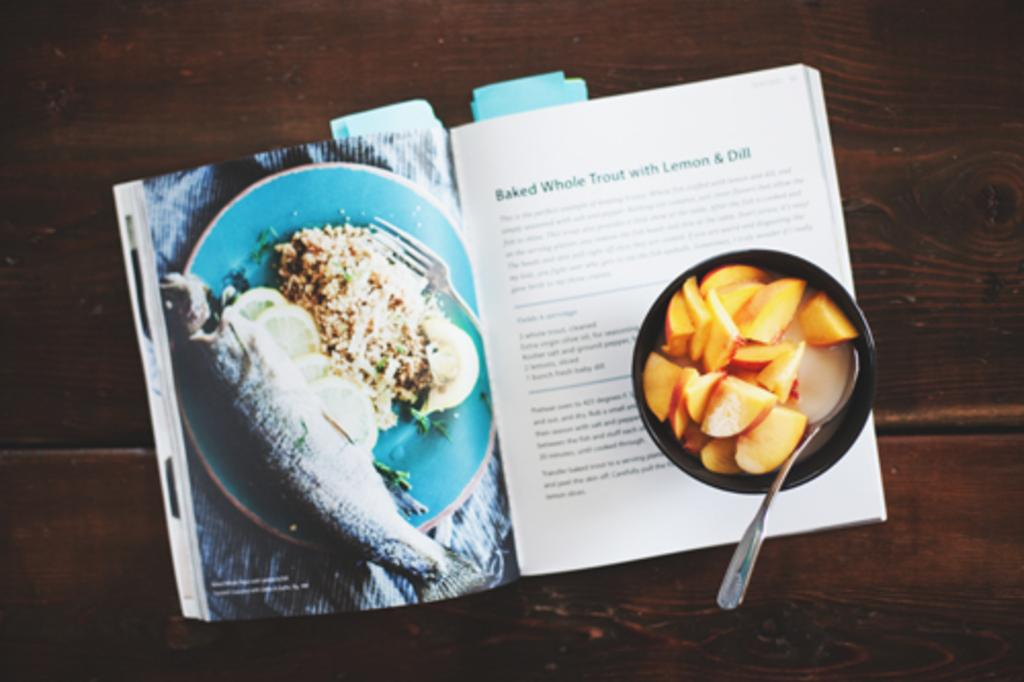What is in the bowl that is visible in the image? There is food in a bowl in the image. What utensil is present in the image? A spoon is visible in the image. What object can be seen on the table in the image? There is a book placed on a table in the image. What type of bells can be heard in the image? There are no bells present in the image. 